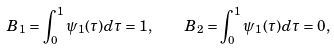<formula> <loc_0><loc_0><loc_500><loc_500>B _ { 1 } = \int _ { 0 } ^ { 1 } \psi _ { 1 } ( \tau ) d \tau = 1 , \quad B _ { 2 } = \int _ { 0 } ^ { 1 } \psi _ { 1 } ( \tau ) d \tau = 0 ,</formula> 